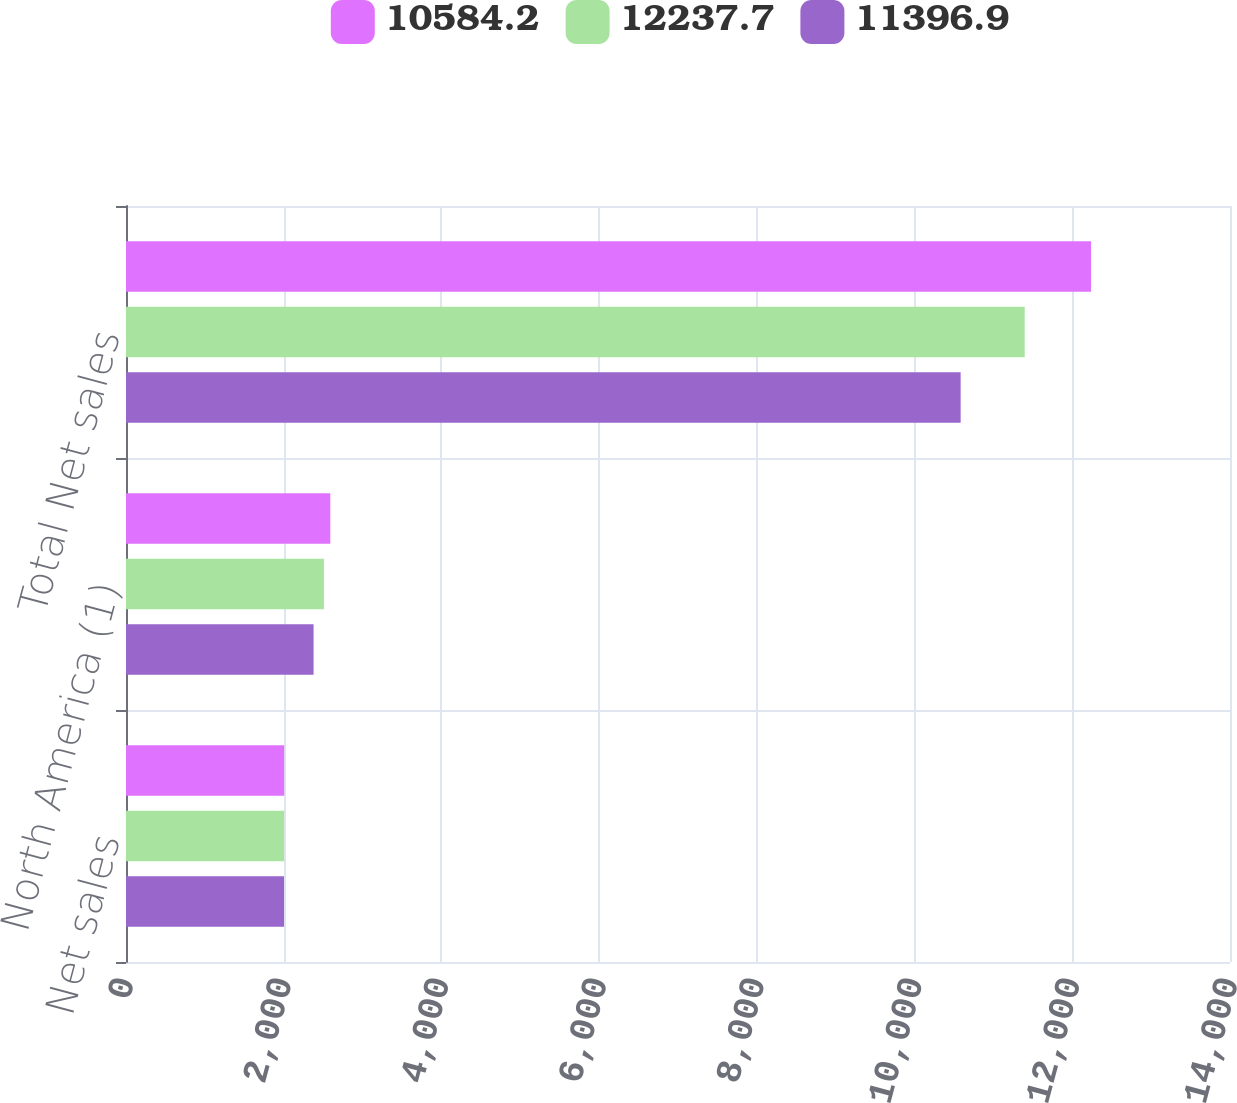<chart> <loc_0><loc_0><loc_500><loc_500><stacked_bar_chart><ecel><fcel>Net sales<fcel>North America (1)<fcel>Total Net sales<nl><fcel>10584.2<fcel>2006<fcel>2590.8<fcel>12237.7<nl><fcel>12237.7<fcel>2005<fcel>2509.8<fcel>11396.9<nl><fcel>11396.9<fcel>2004<fcel>2378.7<fcel>10584.2<nl></chart> 